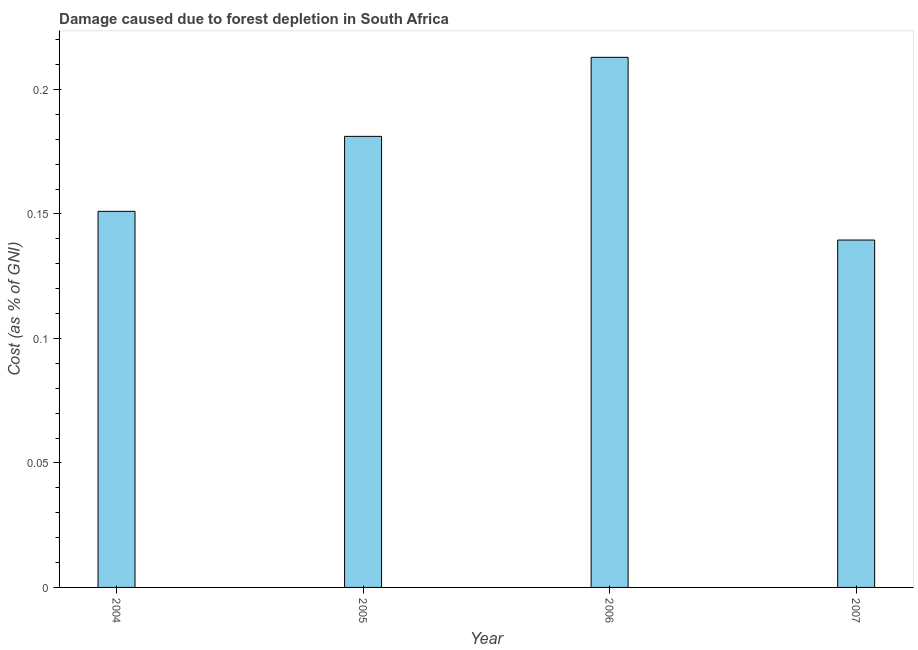Does the graph contain any zero values?
Offer a terse response. No. Does the graph contain grids?
Provide a succinct answer. No. What is the title of the graph?
Make the answer very short. Damage caused due to forest depletion in South Africa. What is the label or title of the X-axis?
Provide a succinct answer. Year. What is the label or title of the Y-axis?
Ensure brevity in your answer.  Cost (as % of GNI). What is the damage caused due to forest depletion in 2005?
Offer a terse response. 0.18. Across all years, what is the maximum damage caused due to forest depletion?
Keep it short and to the point. 0.21. Across all years, what is the minimum damage caused due to forest depletion?
Offer a very short reply. 0.14. In which year was the damage caused due to forest depletion maximum?
Give a very brief answer. 2006. In which year was the damage caused due to forest depletion minimum?
Give a very brief answer. 2007. What is the sum of the damage caused due to forest depletion?
Give a very brief answer. 0.68. What is the difference between the damage caused due to forest depletion in 2005 and 2007?
Your answer should be very brief. 0.04. What is the average damage caused due to forest depletion per year?
Your answer should be compact. 0.17. What is the median damage caused due to forest depletion?
Your answer should be compact. 0.17. What is the ratio of the damage caused due to forest depletion in 2005 to that in 2006?
Make the answer very short. 0.85. Is the difference between the damage caused due to forest depletion in 2005 and 2007 greater than the difference between any two years?
Your answer should be compact. No. What is the difference between the highest and the second highest damage caused due to forest depletion?
Keep it short and to the point. 0.03. What is the difference between the highest and the lowest damage caused due to forest depletion?
Offer a terse response. 0.07. In how many years, is the damage caused due to forest depletion greater than the average damage caused due to forest depletion taken over all years?
Ensure brevity in your answer.  2. What is the Cost (as % of GNI) in 2004?
Your response must be concise. 0.15. What is the Cost (as % of GNI) of 2005?
Your answer should be compact. 0.18. What is the Cost (as % of GNI) in 2006?
Provide a short and direct response. 0.21. What is the Cost (as % of GNI) in 2007?
Your response must be concise. 0.14. What is the difference between the Cost (as % of GNI) in 2004 and 2005?
Keep it short and to the point. -0.03. What is the difference between the Cost (as % of GNI) in 2004 and 2006?
Keep it short and to the point. -0.06. What is the difference between the Cost (as % of GNI) in 2004 and 2007?
Offer a very short reply. 0.01. What is the difference between the Cost (as % of GNI) in 2005 and 2006?
Provide a short and direct response. -0.03. What is the difference between the Cost (as % of GNI) in 2005 and 2007?
Your response must be concise. 0.04. What is the difference between the Cost (as % of GNI) in 2006 and 2007?
Provide a succinct answer. 0.07. What is the ratio of the Cost (as % of GNI) in 2004 to that in 2005?
Keep it short and to the point. 0.83. What is the ratio of the Cost (as % of GNI) in 2004 to that in 2006?
Make the answer very short. 0.71. What is the ratio of the Cost (as % of GNI) in 2004 to that in 2007?
Ensure brevity in your answer.  1.08. What is the ratio of the Cost (as % of GNI) in 2005 to that in 2006?
Provide a short and direct response. 0.85. What is the ratio of the Cost (as % of GNI) in 2005 to that in 2007?
Keep it short and to the point. 1.3. What is the ratio of the Cost (as % of GNI) in 2006 to that in 2007?
Ensure brevity in your answer.  1.53. 